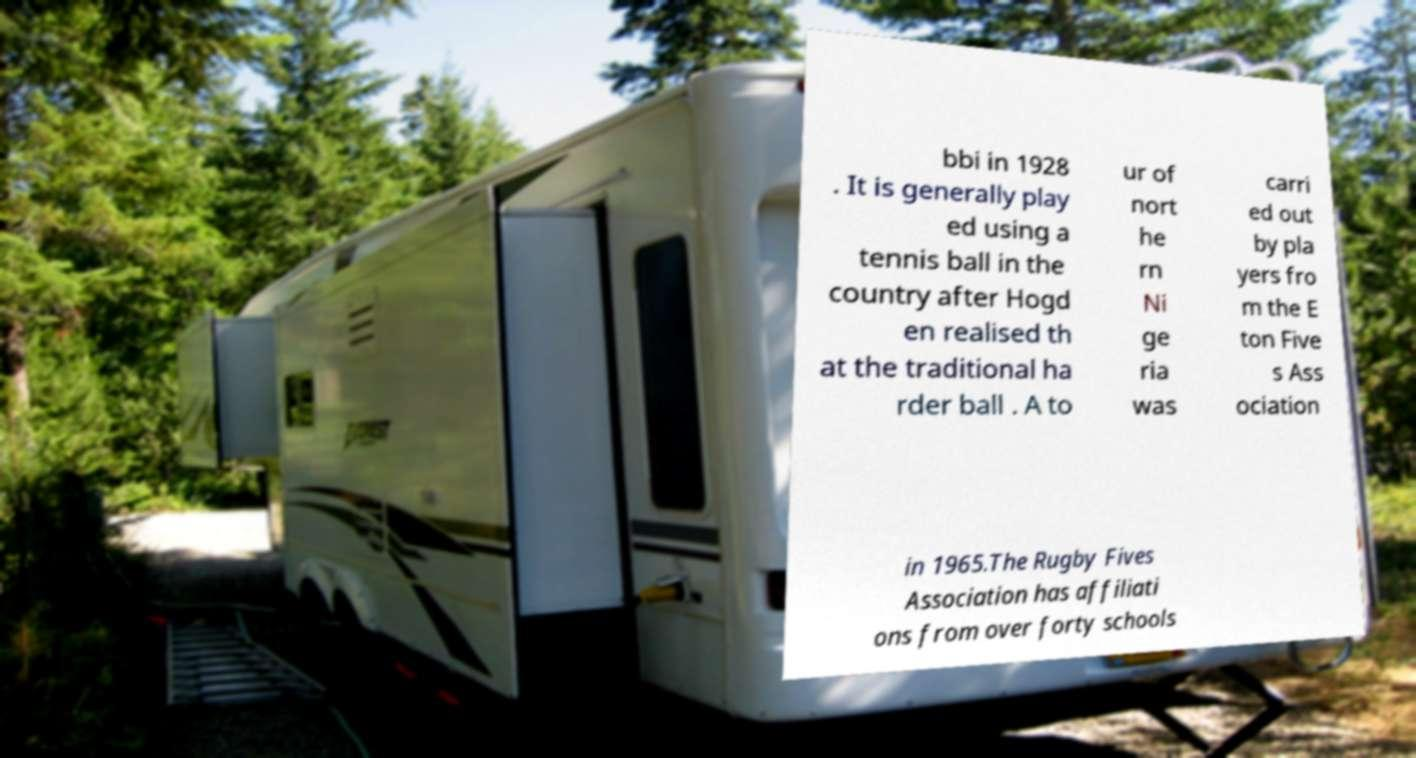Could you assist in decoding the text presented in this image and type it out clearly? bbi in 1928 . It is generally play ed using a tennis ball in the country after Hogd en realised th at the traditional ha rder ball . A to ur of nort he rn Ni ge ria was carri ed out by pla yers fro m the E ton Five s Ass ociation in 1965.The Rugby Fives Association has affiliati ons from over forty schools 